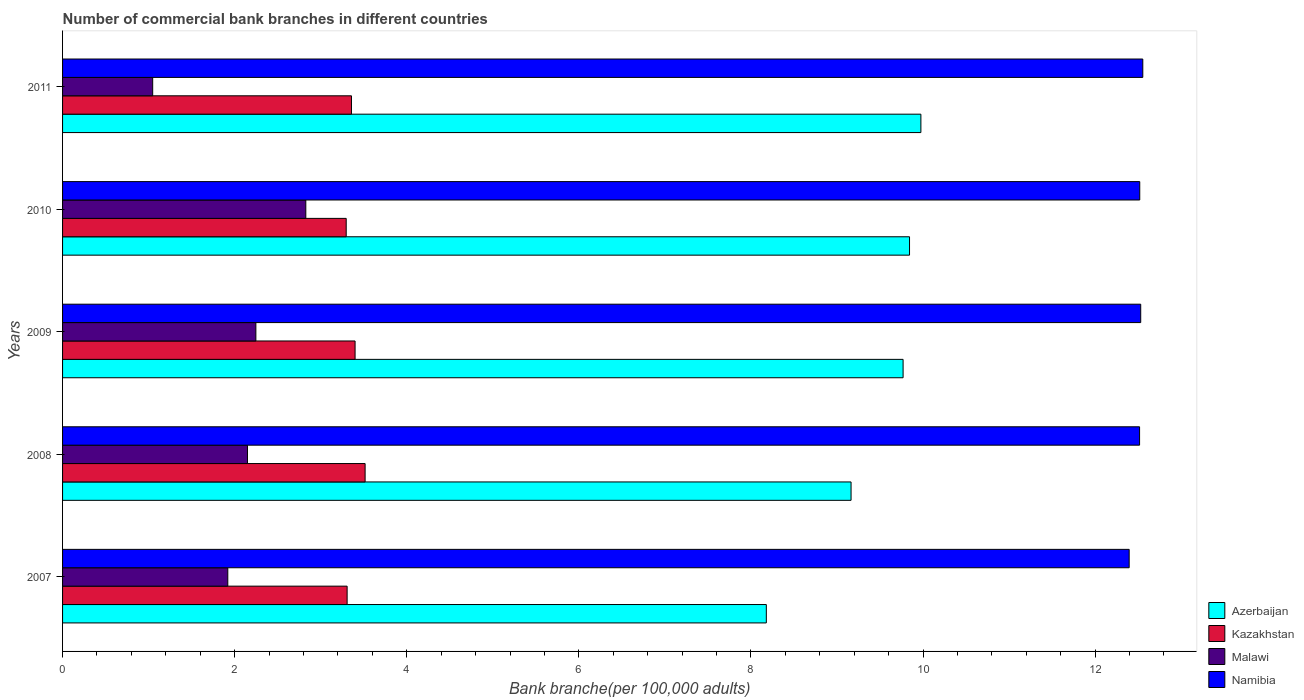How many groups of bars are there?
Offer a terse response. 5. Are the number of bars per tick equal to the number of legend labels?
Make the answer very short. Yes. Are the number of bars on each tick of the Y-axis equal?
Ensure brevity in your answer.  Yes. How many bars are there on the 1st tick from the bottom?
Make the answer very short. 4. What is the number of commercial bank branches in Azerbaijan in 2009?
Make the answer very short. 9.77. Across all years, what is the maximum number of commercial bank branches in Malawi?
Offer a terse response. 2.83. Across all years, what is the minimum number of commercial bank branches in Namibia?
Keep it short and to the point. 12.4. In which year was the number of commercial bank branches in Malawi minimum?
Provide a short and direct response. 2011. What is the total number of commercial bank branches in Namibia in the graph?
Provide a short and direct response. 62.52. What is the difference between the number of commercial bank branches in Malawi in 2008 and that in 2010?
Keep it short and to the point. -0.68. What is the difference between the number of commercial bank branches in Malawi in 2010 and the number of commercial bank branches in Namibia in 2009?
Your response must be concise. -9.7. What is the average number of commercial bank branches in Namibia per year?
Your response must be concise. 12.5. In the year 2011, what is the difference between the number of commercial bank branches in Azerbaijan and number of commercial bank branches in Malawi?
Your response must be concise. 8.93. In how many years, is the number of commercial bank branches in Azerbaijan greater than 4.4 ?
Provide a short and direct response. 5. What is the ratio of the number of commercial bank branches in Namibia in 2007 to that in 2009?
Give a very brief answer. 0.99. What is the difference between the highest and the second highest number of commercial bank branches in Kazakhstan?
Give a very brief answer. 0.12. What is the difference between the highest and the lowest number of commercial bank branches in Kazakhstan?
Make the answer very short. 0.22. Is the sum of the number of commercial bank branches in Azerbaijan in 2008 and 2011 greater than the maximum number of commercial bank branches in Malawi across all years?
Give a very brief answer. Yes. What does the 4th bar from the top in 2008 represents?
Provide a succinct answer. Azerbaijan. What does the 4th bar from the bottom in 2007 represents?
Give a very brief answer. Namibia. How many years are there in the graph?
Ensure brevity in your answer.  5. Are the values on the major ticks of X-axis written in scientific E-notation?
Your answer should be very brief. No. Does the graph contain any zero values?
Your response must be concise. No. Does the graph contain grids?
Offer a very short reply. No. Where does the legend appear in the graph?
Ensure brevity in your answer.  Bottom right. How many legend labels are there?
Make the answer very short. 4. How are the legend labels stacked?
Give a very brief answer. Vertical. What is the title of the graph?
Provide a short and direct response. Number of commercial bank branches in different countries. What is the label or title of the X-axis?
Ensure brevity in your answer.  Bank branche(per 100,0 adults). What is the Bank branche(per 100,000 adults) of Azerbaijan in 2007?
Your answer should be very brief. 8.18. What is the Bank branche(per 100,000 adults) of Kazakhstan in 2007?
Provide a succinct answer. 3.31. What is the Bank branche(per 100,000 adults) in Malawi in 2007?
Give a very brief answer. 1.92. What is the Bank branche(per 100,000 adults) of Namibia in 2007?
Ensure brevity in your answer.  12.4. What is the Bank branche(per 100,000 adults) in Azerbaijan in 2008?
Your response must be concise. 9.16. What is the Bank branche(per 100,000 adults) of Kazakhstan in 2008?
Provide a short and direct response. 3.52. What is the Bank branche(per 100,000 adults) of Malawi in 2008?
Make the answer very short. 2.15. What is the Bank branche(per 100,000 adults) of Namibia in 2008?
Your answer should be very brief. 12.52. What is the Bank branche(per 100,000 adults) of Azerbaijan in 2009?
Provide a succinct answer. 9.77. What is the Bank branche(per 100,000 adults) of Kazakhstan in 2009?
Your answer should be compact. 3.4. What is the Bank branche(per 100,000 adults) in Malawi in 2009?
Your response must be concise. 2.25. What is the Bank branche(per 100,000 adults) in Namibia in 2009?
Give a very brief answer. 12.53. What is the Bank branche(per 100,000 adults) of Azerbaijan in 2010?
Your response must be concise. 9.84. What is the Bank branche(per 100,000 adults) in Kazakhstan in 2010?
Give a very brief answer. 3.3. What is the Bank branche(per 100,000 adults) in Malawi in 2010?
Keep it short and to the point. 2.83. What is the Bank branche(per 100,000 adults) of Namibia in 2010?
Provide a short and direct response. 12.52. What is the Bank branche(per 100,000 adults) of Azerbaijan in 2011?
Offer a terse response. 9.98. What is the Bank branche(per 100,000 adults) of Kazakhstan in 2011?
Provide a succinct answer. 3.36. What is the Bank branche(per 100,000 adults) in Malawi in 2011?
Make the answer very short. 1.05. What is the Bank branche(per 100,000 adults) in Namibia in 2011?
Give a very brief answer. 12.55. Across all years, what is the maximum Bank branche(per 100,000 adults) in Azerbaijan?
Offer a very short reply. 9.98. Across all years, what is the maximum Bank branche(per 100,000 adults) of Kazakhstan?
Provide a short and direct response. 3.52. Across all years, what is the maximum Bank branche(per 100,000 adults) in Malawi?
Give a very brief answer. 2.83. Across all years, what is the maximum Bank branche(per 100,000 adults) of Namibia?
Provide a succinct answer. 12.55. Across all years, what is the minimum Bank branche(per 100,000 adults) in Azerbaijan?
Provide a short and direct response. 8.18. Across all years, what is the minimum Bank branche(per 100,000 adults) in Kazakhstan?
Ensure brevity in your answer.  3.3. Across all years, what is the minimum Bank branche(per 100,000 adults) of Malawi?
Your answer should be very brief. 1.05. Across all years, what is the minimum Bank branche(per 100,000 adults) in Namibia?
Make the answer very short. 12.4. What is the total Bank branche(per 100,000 adults) in Azerbaijan in the graph?
Offer a terse response. 46.93. What is the total Bank branche(per 100,000 adults) of Kazakhstan in the graph?
Keep it short and to the point. 16.88. What is the total Bank branche(per 100,000 adults) of Malawi in the graph?
Give a very brief answer. 10.19. What is the total Bank branche(per 100,000 adults) of Namibia in the graph?
Your answer should be compact. 62.52. What is the difference between the Bank branche(per 100,000 adults) in Azerbaijan in 2007 and that in 2008?
Make the answer very short. -0.98. What is the difference between the Bank branche(per 100,000 adults) of Kazakhstan in 2007 and that in 2008?
Provide a succinct answer. -0.21. What is the difference between the Bank branche(per 100,000 adults) of Malawi in 2007 and that in 2008?
Keep it short and to the point. -0.23. What is the difference between the Bank branche(per 100,000 adults) in Namibia in 2007 and that in 2008?
Give a very brief answer. -0.12. What is the difference between the Bank branche(per 100,000 adults) in Azerbaijan in 2007 and that in 2009?
Offer a terse response. -1.59. What is the difference between the Bank branche(per 100,000 adults) in Kazakhstan in 2007 and that in 2009?
Your answer should be compact. -0.09. What is the difference between the Bank branche(per 100,000 adults) in Malawi in 2007 and that in 2009?
Keep it short and to the point. -0.33. What is the difference between the Bank branche(per 100,000 adults) in Namibia in 2007 and that in 2009?
Ensure brevity in your answer.  -0.13. What is the difference between the Bank branche(per 100,000 adults) in Azerbaijan in 2007 and that in 2010?
Give a very brief answer. -1.66. What is the difference between the Bank branche(per 100,000 adults) in Kazakhstan in 2007 and that in 2010?
Offer a very short reply. 0.01. What is the difference between the Bank branche(per 100,000 adults) of Malawi in 2007 and that in 2010?
Make the answer very short. -0.91. What is the difference between the Bank branche(per 100,000 adults) of Namibia in 2007 and that in 2010?
Your response must be concise. -0.12. What is the difference between the Bank branche(per 100,000 adults) of Azerbaijan in 2007 and that in 2011?
Provide a short and direct response. -1.8. What is the difference between the Bank branche(per 100,000 adults) in Kazakhstan in 2007 and that in 2011?
Your answer should be very brief. -0.05. What is the difference between the Bank branche(per 100,000 adults) in Malawi in 2007 and that in 2011?
Give a very brief answer. 0.87. What is the difference between the Bank branche(per 100,000 adults) of Namibia in 2007 and that in 2011?
Make the answer very short. -0.16. What is the difference between the Bank branche(per 100,000 adults) of Azerbaijan in 2008 and that in 2009?
Your answer should be very brief. -0.6. What is the difference between the Bank branche(per 100,000 adults) in Kazakhstan in 2008 and that in 2009?
Provide a succinct answer. 0.12. What is the difference between the Bank branche(per 100,000 adults) of Malawi in 2008 and that in 2009?
Provide a succinct answer. -0.1. What is the difference between the Bank branche(per 100,000 adults) of Namibia in 2008 and that in 2009?
Provide a short and direct response. -0.01. What is the difference between the Bank branche(per 100,000 adults) of Azerbaijan in 2008 and that in 2010?
Make the answer very short. -0.68. What is the difference between the Bank branche(per 100,000 adults) of Kazakhstan in 2008 and that in 2010?
Provide a succinct answer. 0.22. What is the difference between the Bank branche(per 100,000 adults) in Malawi in 2008 and that in 2010?
Provide a succinct answer. -0.68. What is the difference between the Bank branche(per 100,000 adults) of Namibia in 2008 and that in 2010?
Give a very brief answer. -0. What is the difference between the Bank branche(per 100,000 adults) of Azerbaijan in 2008 and that in 2011?
Your answer should be compact. -0.81. What is the difference between the Bank branche(per 100,000 adults) of Kazakhstan in 2008 and that in 2011?
Your answer should be very brief. 0.16. What is the difference between the Bank branche(per 100,000 adults) of Malawi in 2008 and that in 2011?
Provide a short and direct response. 1.1. What is the difference between the Bank branche(per 100,000 adults) of Namibia in 2008 and that in 2011?
Ensure brevity in your answer.  -0.04. What is the difference between the Bank branche(per 100,000 adults) in Azerbaijan in 2009 and that in 2010?
Keep it short and to the point. -0.07. What is the difference between the Bank branche(per 100,000 adults) of Kazakhstan in 2009 and that in 2010?
Offer a very short reply. 0.1. What is the difference between the Bank branche(per 100,000 adults) in Malawi in 2009 and that in 2010?
Keep it short and to the point. -0.58. What is the difference between the Bank branche(per 100,000 adults) of Namibia in 2009 and that in 2010?
Your response must be concise. 0.01. What is the difference between the Bank branche(per 100,000 adults) of Azerbaijan in 2009 and that in 2011?
Your answer should be compact. -0.21. What is the difference between the Bank branche(per 100,000 adults) in Kazakhstan in 2009 and that in 2011?
Ensure brevity in your answer.  0.04. What is the difference between the Bank branche(per 100,000 adults) of Malawi in 2009 and that in 2011?
Your answer should be compact. 1.2. What is the difference between the Bank branche(per 100,000 adults) in Namibia in 2009 and that in 2011?
Offer a very short reply. -0.02. What is the difference between the Bank branche(per 100,000 adults) of Azerbaijan in 2010 and that in 2011?
Your response must be concise. -0.13. What is the difference between the Bank branche(per 100,000 adults) in Kazakhstan in 2010 and that in 2011?
Provide a succinct answer. -0.06. What is the difference between the Bank branche(per 100,000 adults) of Malawi in 2010 and that in 2011?
Offer a very short reply. 1.78. What is the difference between the Bank branche(per 100,000 adults) in Namibia in 2010 and that in 2011?
Provide a short and direct response. -0.04. What is the difference between the Bank branche(per 100,000 adults) in Azerbaijan in 2007 and the Bank branche(per 100,000 adults) in Kazakhstan in 2008?
Your answer should be very brief. 4.66. What is the difference between the Bank branche(per 100,000 adults) of Azerbaijan in 2007 and the Bank branche(per 100,000 adults) of Malawi in 2008?
Keep it short and to the point. 6.03. What is the difference between the Bank branche(per 100,000 adults) in Azerbaijan in 2007 and the Bank branche(per 100,000 adults) in Namibia in 2008?
Your answer should be very brief. -4.34. What is the difference between the Bank branche(per 100,000 adults) of Kazakhstan in 2007 and the Bank branche(per 100,000 adults) of Malawi in 2008?
Provide a short and direct response. 1.16. What is the difference between the Bank branche(per 100,000 adults) in Kazakhstan in 2007 and the Bank branche(per 100,000 adults) in Namibia in 2008?
Your answer should be very brief. -9.21. What is the difference between the Bank branche(per 100,000 adults) of Malawi in 2007 and the Bank branche(per 100,000 adults) of Namibia in 2008?
Give a very brief answer. -10.6. What is the difference between the Bank branche(per 100,000 adults) in Azerbaijan in 2007 and the Bank branche(per 100,000 adults) in Kazakhstan in 2009?
Offer a terse response. 4.78. What is the difference between the Bank branche(per 100,000 adults) of Azerbaijan in 2007 and the Bank branche(per 100,000 adults) of Malawi in 2009?
Provide a succinct answer. 5.93. What is the difference between the Bank branche(per 100,000 adults) of Azerbaijan in 2007 and the Bank branche(per 100,000 adults) of Namibia in 2009?
Give a very brief answer. -4.35. What is the difference between the Bank branche(per 100,000 adults) of Kazakhstan in 2007 and the Bank branche(per 100,000 adults) of Malawi in 2009?
Your answer should be very brief. 1.06. What is the difference between the Bank branche(per 100,000 adults) in Kazakhstan in 2007 and the Bank branche(per 100,000 adults) in Namibia in 2009?
Make the answer very short. -9.22. What is the difference between the Bank branche(per 100,000 adults) of Malawi in 2007 and the Bank branche(per 100,000 adults) of Namibia in 2009?
Provide a succinct answer. -10.61. What is the difference between the Bank branche(per 100,000 adults) in Azerbaijan in 2007 and the Bank branche(per 100,000 adults) in Kazakhstan in 2010?
Ensure brevity in your answer.  4.88. What is the difference between the Bank branche(per 100,000 adults) in Azerbaijan in 2007 and the Bank branche(per 100,000 adults) in Malawi in 2010?
Your answer should be compact. 5.35. What is the difference between the Bank branche(per 100,000 adults) of Azerbaijan in 2007 and the Bank branche(per 100,000 adults) of Namibia in 2010?
Ensure brevity in your answer.  -4.34. What is the difference between the Bank branche(per 100,000 adults) in Kazakhstan in 2007 and the Bank branche(per 100,000 adults) in Malawi in 2010?
Give a very brief answer. 0.48. What is the difference between the Bank branche(per 100,000 adults) of Kazakhstan in 2007 and the Bank branche(per 100,000 adults) of Namibia in 2010?
Provide a succinct answer. -9.21. What is the difference between the Bank branche(per 100,000 adults) of Malawi in 2007 and the Bank branche(per 100,000 adults) of Namibia in 2010?
Offer a very short reply. -10.6. What is the difference between the Bank branche(per 100,000 adults) of Azerbaijan in 2007 and the Bank branche(per 100,000 adults) of Kazakhstan in 2011?
Ensure brevity in your answer.  4.82. What is the difference between the Bank branche(per 100,000 adults) of Azerbaijan in 2007 and the Bank branche(per 100,000 adults) of Malawi in 2011?
Keep it short and to the point. 7.13. What is the difference between the Bank branche(per 100,000 adults) in Azerbaijan in 2007 and the Bank branche(per 100,000 adults) in Namibia in 2011?
Offer a very short reply. -4.38. What is the difference between the Bank branche(per 100,000 adults) of Kazakhstan in 2007 and the Bank branche(per 100,000 adults) of Malawi in 2011?
Your response must be concise. 2.26. What is the difference between the Bank branche(per 100,000 adults) in Kazakhstan in 2007 and the Bank branche(per 100,000 adults) in Namibia in 2011?
Offer a terse response. -9.25. What is the difference between the Bank branche(per 100,000 adults) in Malawi in 2007 and the Bank branche(per 100,000 adults) in Namibia in 2011?
Your response must be concise. -10.63. What is the difference between the Bank branche(per 100,000 adults) in Azerbaijan in 2008 and the Bank branche(per 100,000 adults) in Kazakhstan in 2009?
Offer a very short reply. 5.76. What is the difference between the Bank branche(per 100,000 adults) in Azerbaijan in 2008 and the Bank branche(per 100,000 adults) in Malawi in 2009?
Give a very brief answer. 6.92. What is the difference between the Bank branche(per 100,000 adults) of Azerbaijan in 2008 and the Bank branche(per 100,000 adults) of Namibia in 2009?
Your response must be concise. -3.37. What is the difference between the Bank branche(per 100,000 adults) of Kazakhstan in 2008 and the Bank branche(per 100,000 adults) of Malawi in 2009?
Your answer should be compact. 1.27. What is the difference between the Bank branche(per 100,000 adults) of Kazakhstan in 2008 and the Bank branche(per 100,000 adults) of Namibia in 2009?
Your response must be concise. -9.01. What is the difference between the Bank branche(per 100,000 adults) of Malawi in 2008 and the Bank branche(per 100,000 adults) of Namibia in 2009?
Make the answer very short. -10.38. What is the difference between the Bank branche(per 100,000 adults) of Azerbaijan in 2008 and the Bank branche(per 100,000 adults) of Kazakhstan in 2010?
Make the answer very short. 5.87. What is the difference between the Bank branche(per 100,000 adults) in Azerbaijan in 2008 and the Bank branche(per 100,000 adults) in Malawi in 2010?
Provide a short and direct response. 6.34. What is the difference between the Bank branche(per 100,000 adults) in Azerbaijan in 2008 and the Bank branche(per 100,000 adults) in Namibia in 2010?
Provide a short and direct response. -3.36. What is the difference between the Bank branche(per 100,000 adults) of Kazakhstan in 2008 and the Bank branche(per 100,000 adults) of Malawi in 2010?
Your answer should be very brief. 0.69. What is the difference between the Bank branche(per 100,000 adults) of Kazakhstan in 2008 and the Bank branche(per 100,000 adults) of Namibia in 2010?
Provide a short and direct response. -9. What is the difference between the Bank branche(per 100,000 adults) of Malawi in 2008 and the Bank branche(per 100,000 adults) of Namibia in 2010?
Keep it short and to the point. -10.37. What is the difference between the Bank branche(per 100,000 adults) of Azerbaijan in 2008 and the Bank branche(per 100,000 adults) of Kazakhstan in 2011?
Provide a short and direct response. 5.81. What is the difference between the Bank branche(per 100,000 adults) of Azerbaijan in 2008 and the Bank branche(per 100,000 adults) of Malawi in 2011?
Offer a very short reply. 8.12. What is the difference between the Bank branche(per 100,000 adults) of Azerbaijan in 2008 and the Bank branche(per 100,000 adults) of Namibia in 2011?
Give a very brief answer. -3.39. What is the difference between the Bank branche(per 100,000 adults) in Kazakhstan in 2008 and the Bank branche(per 100,000 adults) in Malawi in 2011?
Ensure brevity in your answer.  2.47. What is the difference between the Bank branche(per 100,000 adults) of Kazakhstan in 2008 and the Bank branche(per 100,000 adults) of Namibia in 2011?
Your answer should be very brief. -9.04. What is the difference between the Bank branche(per 100,000 adults) in Malawi in 2008 and the Bank branche(per 100,000 adults) in Namibia in 2011?
Your answer should be very brief. -10.41. What is the difference between the Bank branche(per 100,000 adults) in Azerbaijan in 2009 and the Bank branche(per 100,000 adults) in Kazakhstan in 2010?
Your answer should be compact. 6.47. What is the difference between the Bank branche(per 100,000 adults) of Azerbaijan in 2009 and the Bank branche(per 100,000 adults) of Malawi in 2010?
Provide a succinct answer. 6.94. What is the difference between the Bank branche(per 100,000 adults) of Azerbaijan in 2009 and the Bank branche(per 100,000 adults) of Namibia in 2010?
Ensure brevity in your answer.  -2.75. What is the difference between the Bank branche(per 100,000 adults) of Kazakhstan in 2009 and the Bank branche(per 100,000 adults) of Malawi in 2010?
Make the answer very short. 0.57. What is the difference between the Bank branche(per 100,000 adults) of Kazakhstan in 2009 and the Bank branche(per 100,000 adults) of Namibia in 2010?
Make the answer very short. -9.12. What is the difference between the Bank branche(per 100,000 adults) in Malawi in 2009 and the Bank branche(per 100,000 adults) in Namibia in 2010?
Provide a short and direct response. -10.27. What is the difference between the Bank branche(per 100,000 adults) in Azerbaijan in 2009 and the Bank branche(per 100,000 adults) in Kazakhstan in 2011?
Your answer should be compact. 6.41. What is the difference between the Bank branche(per 100,000 adults) in Azerbaijan in 2009 and the Bank branche(per 100,000 adults) in Malawi in 2011?
Keep it short and to the point. 8.72. What is the difference between the Bank branche(per 100,000 adults) in Azerbaijan in 2009 and the Bank branche(per 100,000 adults) in Namibia in 2011?
Offer a terse response. -2.79. What is the difference between the Bank branche(per 100,000 adults) in Kazakhstan in 2009 and the Bank branche(per 100,000 adults) in Malawi in 2011?
Give a very brief answer. 2.35. What is the difference between the Bank branche(per 100,000 adults) in Kazakhstan in 2009 and the Bank branche(per 100,000 adults) in Namibia in 2011?
Provide a short and direct response. -9.15. What is the difference between the Bank branche(per 100,000 adults) in Malawi in 2009 and the Bank branche(per 100,000 adults) in Namibia in 2011?
Provide a short and direct response. -10.31. What is the difference between the Bank branche(per 100,000 adults) in Azerbaijan in 2010 and the Bank branche(per 100,000 adults) in Kazakhstan in 2011?
Provide a succinct answer. 6.49. What is the difference between the Bank branche(per 100,000 adults) in Azerbaijan in 2010 and the Bank branche(per 100,000 adults) in Malawi in 2011?
Give a very brief answer. 8.8. What is the difference between the Bank branche(per 100,000 adults) of Azerbaijan in 2010 and the Bank branche(per 100,000 adults) of Namibia in 2011?
Provide a succinct answer. -2.71. What is the difference between the Bank branche(per 100,000 adults) in Kazakhstan in 2010 and the Bank branche(per 100,000 adults) in Malawi in 2011?
Keep it short and to the point. 2.25. What is the difference between the Bank branche(per 100,000 adults) in Kazakhstan in 2010 and the Bank branche(per 100,000 adults) in Namibia in 2011?
Your answer should be very brief. -9.26. What is the difference between the Bank branche(per 100,000 adults) in Malawi in 2010 and the Bank branche(per 100,000 adults) in Namibia in 2011?
Make the answer very short. -9.73. What is the average Bank branche(per 100,000 adults) in Azerbaijan per year?
Give a very brief answer. 9.39. What is the average Bank branche(per 100,000 adults) of Kazakhstan per year?
Keep it short and to the point. 3.38. What is the average Bank branche(per 100,000 adults) in Malawi per year?
Your response must be concise. 2.04. What is the average Bank branche(per 100,000 adults) of Namibia per year?
Keep it short and to the point. 12.5. In the year 2007, what is the difference between the Bank branche(per 100,000 adults) in Azerbaijan and Bank branche(per 100,000 adults) in Kazakhstan?
Your answer should be very brief. 4.87. In the year 2007, what is the difference between the Bank branche(per 100,000 adults) of Azerbaijan and Bank branche(per 100,000 adults) of Malawi?
Give a very brief answer. 6.26. In the year 2007, what is the difference between the Bank branche(per 100,000 adults) of Azerbaijan and Bank branche(per 100,000 adults) of Namibia?
Your answer should be very brief. -4.22. In the year 2007, what is the difference between the Bank branche(per 100,000 adults) of Kazakhstan and Bank branche(per 100,000 adults) of Malawi?
Your response must be concise. 1.39. In the year 2007, what is the difference between the Bank branche(per 100,000 adults) of Kazakhstan and Bank branche(per 100,000 adults) of Namibia?
Your answer should be very brief. -9.09. In the year 2007, what is the difference between the Bank branche(per 100,000 adults) of Malawi and Bank branche(per 100,000 adults) of Namibia?
Your response must be concise. -10.48. In the year 2008, what is the difference between the Bank branche(per 100,000 adults) of Azerbaijan and Bank branche(per 100,000 adults) of Kazakhstan?
Your answer should be compact. 5.65. In the year 2008, what is the difference between the Bank branche(per 100,000 adults) in Azerbaijan and Bank branche(per 100,000 adults) in Malawi?
Offer a terse response. 7.01. In the year 2008, what is the difference between the Bank branche(per 100,000 adults) of Azerbaijan and Bank branche(per 100,000 adults) of Namibia?
Give a very brief answer. -3.35. In the year 2008, what is the difference between the Bank branche(per 100,000 adults) of Kazakhstan and Bank branche(per 100,000 adults) of Malawi?
Your answer should be very brief. 1.37. In the year 2008, what is the difference between the Bank branche(per 100,000 adults) in Kazakhstan and Bank branche(per 100,000 adults) in Namibia?
Your answer should be very brief. -9. In the year 2008, what is the difference between the Bank branche(per 100,000 adults) in Malawi and Bank branche(per 100,000 adults) in Namibia?
Offer a terse response. -10.37. In the year 2009, what is the difference between the Bank branche(per 100,000 adults) in Azerbaijan and Bank branche(per 100,000 adults) in Kazakhstan?
Keep it short and to the point. 6.37. In the year 2009, what is the difference between the Bank branche(per 100,000 adults) of Azerbaijan and Bank branche(per 100,000 adults) of Malawi?
Your answer should be very brief. 7.52. In the year 2009, what is the difference between the Bank branche(per 100,000 adults) in Azerbaijan and Bank branche(per 100,000 adults) in Namibia?
Provide a succinct answer. -2.76. In the year 2009, what is the difference between the Bank branche(per 100,000 adults) of Kazakhstan and Bank branche(per 100,000 adults) of Malawi?
Give a very brief answer. 1.15. In the year 2009, what is the difference between the Bank branche(per 100,000 adults) of Kazakhstan and Bank branche(per 100,000 adults) of Namibia?
Ensure brevity in your answer.  -9.13. In the year 2009, what is the difference between the Bank branche(per 100,000 adults) of Malawi and Bank branche(per 100,000 adults) of Namibia?
Your answer should be compact. -10.28. In the year 2010, what is the difference between the Bank branche(per 100,000 adults) in Azerbaijan and Bank branche(per 100,000 adults) in Kazakhstan?
Offer a very short reply. 6.55. In the year 2010, what is the difference between the Bank branche(per 100,000 adults) in Azerbaijan and Bank branche(per 100,000 adults) in Malawi?
Give a very brief answer. 7.02. In the year 2010, what is the difference between the Bank branche(per 100,000 adults) in Azerbaijan and Bank branche(per 100,000 adults) in Namibia?
Your answer should be compact. -2.68. In the year 2010, what is the difference between the Bank branche(per 100,000 adults) of Kazakhstan and Bank branche(per 100,000 adults) of Malawi?
Keep it short and to the point. 0.47. In the year 2010, what is the difference between the Bank branche(per 100,000 adults) of Kazakhstan and Bank branche(per 100,000 adults) of Namibia?
Give a very brief answer. -9.22. In the year 2010, what is the difference between the Bank branche(per 100,000 adults) in Malawi and Bank branche(per 100,000 adults) in Namibia?
Provide a short and direct response. -9.69. In the year 2011, what is the difference between the Bank branche(per 100,000 adults) in Azerbaijan and Bank branche(per 100,000 adults) in Kazakhstan?
Offer a terse response. 6.62. In the year 2011, what is the difference between the Bank branche(per 100,000 adults) in Azerbaijan and Bank branche(per 100,000 adults) in Malawi?
Offer a very short reply. 8.93. In the year 2011, what is the difference between the Bank branche(per 100,000 adults) of Azerbaijan and Bank branche(per 100,000 adults) of Namibia?
Make the answer very short. -2.58. In the year 2011, what is the difference between the Bank branche(per 100,000 adults) in Kazakhstan and Bank branche(per 100,000 adults) in Malawi?
Provide a succinct answer. 2.31. In the year 2011, what is the difference between the Bank branche(per 100,000 adults) of Kazakhstan and Bank branche(per 100,000 adults) of Namibia?
Offer a terse response. -9.2. In the year 2011, what is the difference between the Bank branche(per 100,000 adults) in Malawi and Bank branche(per 100,000 adults) in Namibia?
Offer a very short reply. -11.51. What is the ratio of the Bank branche(per 100,000 adults) of Azerbaijan in 2007 to that in 2008?
Offer a very short reply. 0.89. What is the ratio of the Bank branche(per 100,000 adults) in Kazakhstan in 2007 to that in 2008?
Offer a very short reply. 0.94. What is the ratio of the Bank branche(per 100,000 adults) of Malawi in 2007 to that in 2008?
Your answer should be very brief. 0.89. What is the ratio of the Bank branche(per 100,000 adults) in Namibia in 2007 to that in 2008?
Offer a terse response. 0.99. What is the ratio of the Bank branche(per 100,000 adults) in Azerbaijan in 2007 to that in 2009?
Your answer should be compact. 0.84. What is the ratio of the Bank branche(per 100,000 adults) of Kazakhstan in 2007 to that in 2009?
Give a very brief answer. 0.97. What is the ratio of the Bank branche(per 100,000 adults) in Malawi in 2007 to that in 2009?
Offer a very short reply. 0.85. What is the ratio of the Bank branche(per 100,000 adults) in Namibia in 2007 to that in 2009?
Your answer should be very brief. 0.99. What is the ratio of the Bank branche(per 100,000 adults) in Azerbaijan in 2007 to that in 2010?
Give a very brief answer. 0.83. What is the ratio of the Bank branche(per 100,000 adults) of Kazakhstan in 2007 to that in 2010?
Offer a very short reply. 1. What is the ratio of the Bank branche(per 100,000 adults) of Malawi in 2007 to that in 2010?
Give a very brief answer. 0.68. What is the ratio of the Bank branche(per 100,000 adults) of Namibia in 2007 to that in 2010?
Keep it short and to the point. 0.99. What is the ratio of the Bank branche(per 100,000 adults) in Azerbaijan in 2007 to that in 2011?
Your response must be concise. 0.82. What is the ratio of the Bank branche(per 100,000 adults) in Malawi in 2007 to that in 2011?
Ensure brevity in your answer.  1.83. What is the ratio of the Bank branche(per 100,000 adults) of Namibia in 2007 to that in 2011?
Ensure brevity in your answer.  0.99. What is the ratio of the Bank branche(per 100,000 adults) in Azerbaijan in 2008 to that in 2009?
Offer a very short reply. 0.94. What is the ratio of the Bank branche(per 100,000 adults) in Kazakhstan in 2008 to that in 2009?
Make the answer very short. 1.03. What is the ratio of the Bank branche(per 100,000 adults) of Malawi in 2008 to that in 2009?
Provide a succinct answer. 0.96. What is the ratio of the Bank branche(per 100,000 adults) of Namibia in 2008 to that in 2009?
Your response must be concise. 1. What is the ratio of the Bank branche(per 100,000 adults) in Azerbaijan in 2008 to that in 2010?
Ensure brevity in your answer.  0.93. What is the ratio of the Bank branche(per 100,000 adults) in Kazakhstan in 2008 to that in 2010?
Offer a very short reply. 1.07. What is the ratio of the Bank branche(per 100,000 adults) of Malawi in 2008 to that in 2010?
Offer a terse response. 0.76. What is the ratio of the Bank branche(per 100,000 adults) of Azerbaijan in 2008 to that in 2011?
Your response must be concise. 0.92. What is the ratio of the Bank branche(per 100,000 adults) in Kazakhstan in 2008 to that in 2011?
Your answer should be very brief. 1.05. What is the ratio of the Bank branche(per 100,000 adults) of Malawi in 2008 to that in 2011?
Ensure brevity in your answer.  2.05. What is the ratio of the Bank branche(per 100,000 adults) of Kazakhstan in 2009 to that in 2010?
Provide a short and direct response. 1.03. What is the ratio of the Bank branche(per 100,000 adults) in Malawi in 2009 to that in 2010?
Provide a succinct answer. 0.79. What is the ratio of the Bank branche(per 100,000 adults) of Namibia in 2009 to that in 2010?
Keep it short and to the point. 1. What is the ratio of the Bank branche(per 100,000 adults) of Azerbaijan in 2009 to that in 2011?
Your response must be concise. 0.98. What is the ratio of the Bank branche(per 100,000 adults) in Kazakhstan in 2009 to that in 2011?
Your answer should be compact. 1.01. What is the ratio of the Bank branche(per 100,000 adults) of Malawi in 2009 to that in 2011?
Your answer should be very brief. 2.14. What is the ratio of the Bank branche(per 100,000 adults) of Namibia in 2009 to that in 2011?
Ensure brevity in your answer.  1. What is the ratio of the Bank branche(per 100,000 adults) in Kazakhstan in 2010 to that in 2011?
Provide a short and direct response. 0.98. What is the ratio of the Bank branche(per 100,000 adults) of Malawi in 2010 to that in 2011?
Your answer should be compact. 2.7. What is the ratio of the Bank branche(per 100,000 adults) of Namibia in 2010 to that in 2011?
Your response must be concise. 1. What is the difference between the highest and the second highest Bank branche(per 100,000 adults) in Azerbaijan?
Your answer should be compact. 0.13. What is the difference between the highest and the second highest Bank branche(per 100,000 adults) of Kazakhstan?
Provide a short and direct response. 0.12. What is the difference between the highest and the second highest Bank branche(per 100,000 adults) of Malawi?
Your answer should be compact. 0.58. What is the difference between the highest and the second highest Bank branche(per 100,000 adults) in Namibia?
Provide a succinct answer. 0.02. What is the difference between the highest and the lowest Bank branche(per 100,000 adults) of Azerbaijan?
Give a very brief answer. 1.8. What is the difference between the highest and the lowest Bank branche(per 100,000 adults) of Kazakhstan?
Provide a short and direct response. 0.22. What is the difference between the highest and the lowest Bank branche(per 100,000 adults) in Malawi?
Keep it short and to the point. 1.78. What is the difference between the highest and the lowest Bank branche(per 100,000 adults) in Namibia?
Ensure brevity in your answer.  0.16. 